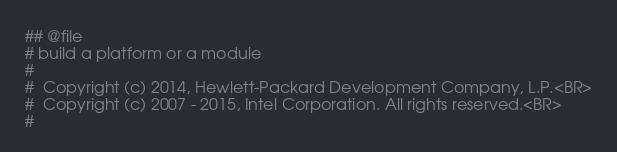<code> <loc_0><loc_0><loc_500><loc_500><_Python_>## @file
# build a platform or a module
#
#  Copyright (c) 2014, Hewlett-Packard Development Company, L.P.<BR>
#  Copyright (c) 2007 - 2015, Intel Corporation. All rights reserved.<BR>
#</code> 